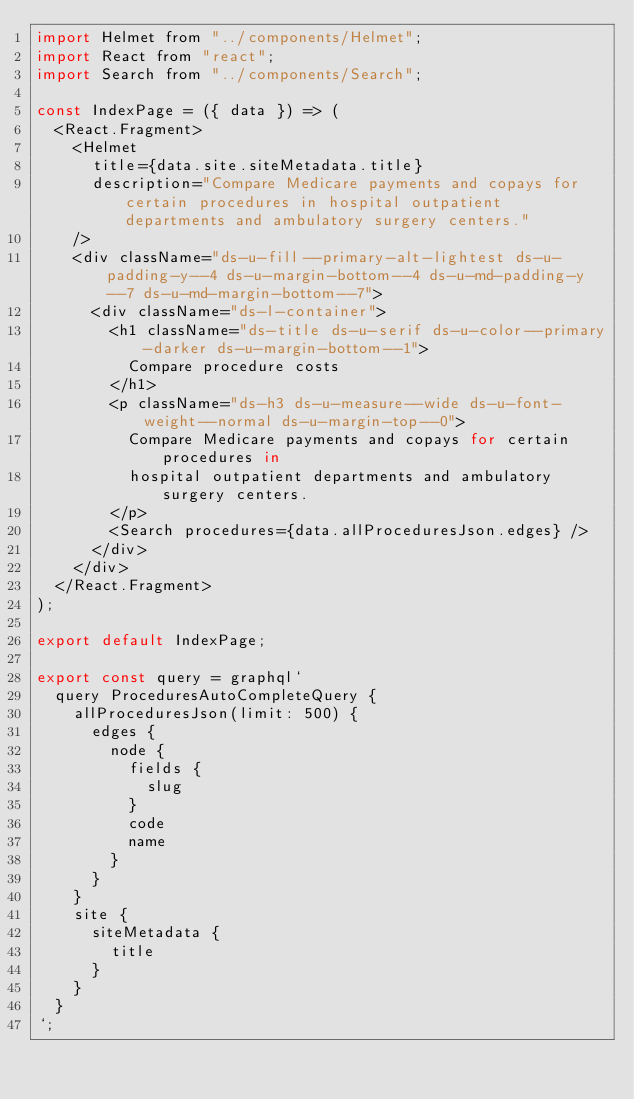Convert code to text. <code><loc_0><loc_0><loc_500><loc_500><_JavaScript_>import Helmet from "../components/Helmet";
import React from "react";
import Search from "../components/Search";

const IndexPage = ({ data }) => (
  <React.Fragment>
    <Helmet
      title={data.site.siteMetadata.title}
      description="Compare Medicare payments and copays for certain procedures in hospital outpatient departments and ambulatory surgery centers."
    />
    <div className="ds-u-fill--primary-alt-lightest ds-u-padding-y--4 ds-u-margin-bottom--4 ds-u-md-padding-y--7 ds-u-md-margin-bottom--7">
      <div className="ds-l-container">
        <h1 className="ds-title ds-u-serif ds-u-color--primary-darker ds-u-margin-bottom--1">
          Compare procedure costs
        </h1>
        <p className="ds-h3 ds-u-measure--wide ds-u-font-weight--normal ds-u-margin-top--0">
          Compare Medicare payments and copays for certain procedures in
          hospital outpatient departments and ambulatory surgery centers.
        </p>
        <Search procedures={data.allProceduresJson.edges} />
      </div>
    </div>
  </React.Fragment>
);

export default IndexPage;

export const query = graphql`
  query ProceduresAutoCompleteQuery {
    allProceduresJson(limit: 500) {
      edges {
        node {
          fields {
            slug
          }
          code
          name
        }
      }
    }
    site {
      siteMetadata {
        title
      }
    }
  }
`;
</code> 